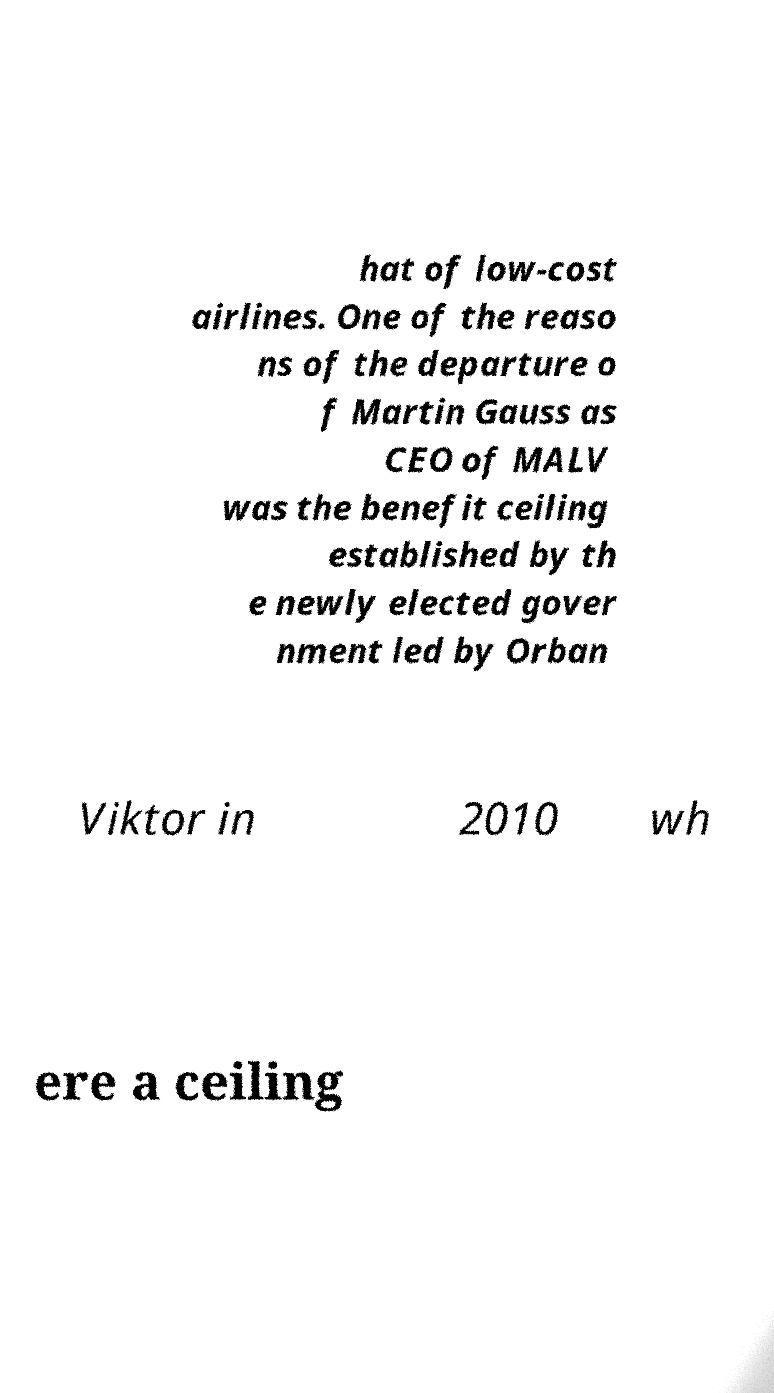Can you accurately transcribe the text from the provided image for me? hat of low-cost airlines. One of the reaso ns of the departure o f Martin Gauss as CEO of MALV was the benefit ceiling established by th e newly elected gover nment led by Orban Viktor in 2010 wh ere a ceiling 